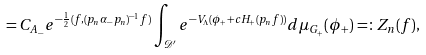Convert formula to latex. <formula><loc_0><loc_0><loc_500><loc_500>= C _ { A _ { - } } e ^ { - \frac { 1 } { 2 } ( f , ( p _ { n } \alpha _ { - } p _ { n } ) ^ { - 1 } f ) } \int _ { { \mathcal { D } } ^ { \prime } } e ^ { - V _ { \Lambda } ( \phi _ { + } + c H _ { + } ( p _ { n } f ) ) } d \mu _ { G _ { + } } ( \phi _ { + } ) = \colon Z _ { n } ( f ) ,</formula> 